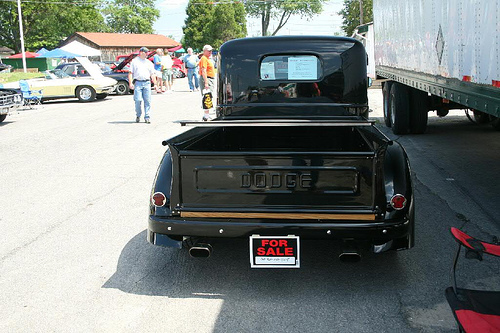<image>
Is there a pickup on the truck? No. The pickup is not positioned on the truck. They may be near each other, but the pickup is not supported by or resting on top of the truck. 